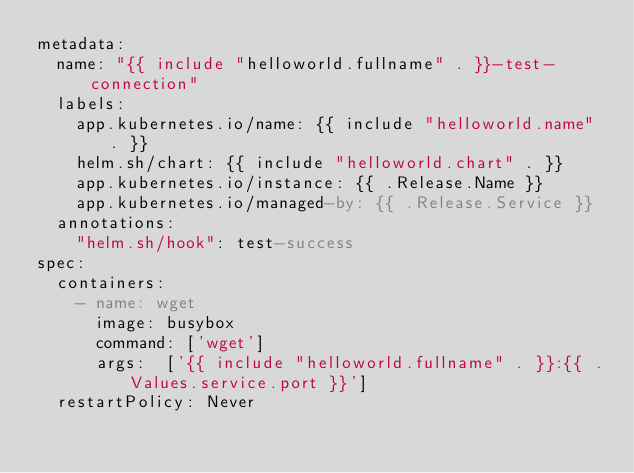<code> <loc_0><loc_0><loc_500><loc_500><_YAML_>metadata:
  name: "{{ include "helloworld.fullname" . }}-test-connection"
  labels:
    app.kubernetes.io/name: {{ include "helloworld.name" . }}
    helm.sh/chart: {{ include "helloworld.chart" . }}
    app.kubernetes.io/instance: {{ .Release.Name }}
    app.kubernetes.io/managed-by: {{ .Release.Service }}
  annotations:
    "helm.sh/hook": test-success
spec:
  containers:
    - name: wget
      image: busybox
      command: ['wget']
      args:  ['{{ include "helloworld.fullname" . }}:{{ .Values.service.port }}']
  restartPolicy: Never
</code> 